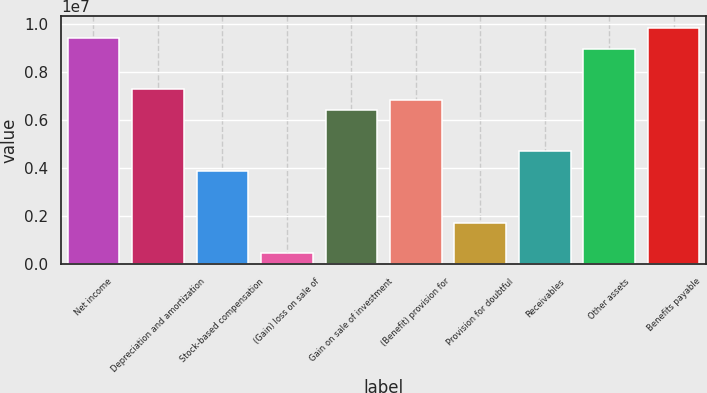Convert chart. <chart><loc_0><loc_0><loc_500><loc_500><bar_chart><fcel>Net income<fcel>Depreciation and amortization<fcel>Stock-based compensation<fcel>(Gain) loss on sale of<fcel>Gain on sale of investment<fcel>(Benefit) provision for<fcel>Provision for doubtful<fcel>Receivables<fcel>Other assets<fcel>Benefits payable<nl><fcel>9.3915e+06<fcel>7.25722e+06<fcel>3.84236e+06<fcel>427512<fcel>6.4035e+06<fcel>6.83036e+06<fcel>1.70808e+06<fcel>4.69608e+06<fcel>8.96464e+06<fcel>9.81836e+06<nl></chart> 